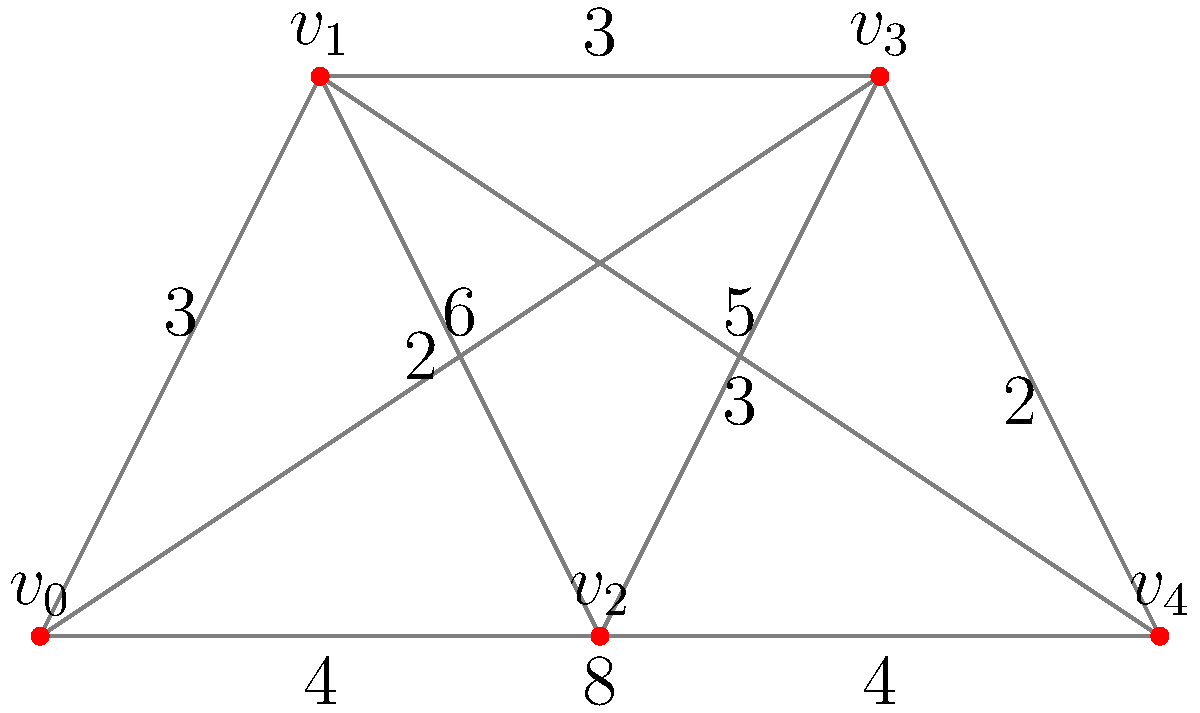As a hockey player, you need to skate from point $v_0$ to point $v_4$ on the rink. The diagram represents different paths you can take, with the numbers indicating the time (in seconds) it takes to skate between two points. What is the shortest time in which you can complete this route? To find the shortest path from $v_0$ to $v_4$, we need to consider all possible routes and calculate their total times:

1. $v_0 \rightarrow v_4$: 8 seconds
2. $v_0 \rightarrow v_1 \rightarrow v_4$: $3 + 5 = 8$ seconds
3. $v_0 \rightarrow v_2 \rightarrow v_4$: $4 + 4 = 8$ seconds
4. $v_0 \rightarrow v_3 \rightarrow v_4$: $6 + 2 = 8$ seconds
5. $v_0 \rightarrow v_1 \rightarrow v_2 \rightarrow v_4$: $3 + 2 + 4 = 9$ seconds
6. $v_0 \rightarrow v_1 \rightarrow v_3 \rightarrow v_4$: $3 + 3 + 2 = 8$ seconds
7. $v_0 \rightarrow v_2 \rightarrow v_3 \rightarrow v_4$: $4 + 3 + 2 = 9$ seconds

The shortest time among all these paths is 8 seconds, which can be achieved through multiple routes:
- Direct path: $v_0 \rightarrow v_4$
- $v_0 \rightarrow v_1 \rightarrow v_4$
- $v_0 \rightarrow v_2 \rightarrow v_4$
- $v_0 \rightarrow v_3 \rightarrow v_4$
- $v_0 \rightarrow v_1 \rightarrow v_3 \rightarrow v_4$
Answer: 8 seconds 